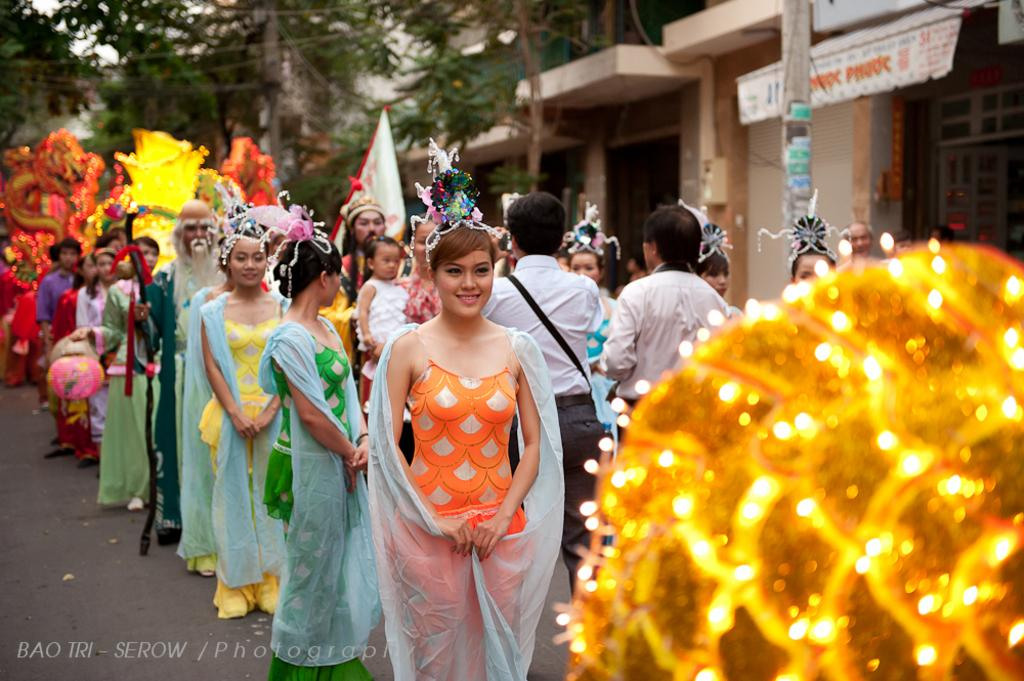How many people are present in the image? There are many people in the image. What are the people wearing in the image? The people are wearing different types of costumes. What can be seen in the background of the image? There are buildings and trees in the backdrop of the image. How many lizards are sitting on the sofa in the image? There are no lizards or sofas present in the image. What color is the rose in the image? There is no rose present in the image. 